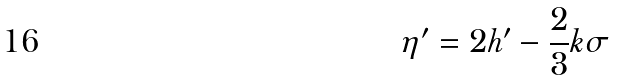<formula> <loc_0><loc_0><loc_500><loc_500>\eta ^ { \prime } = 2 h ^ { \prime } - \frac { 2 } { 3 } k \sigma</formula> 